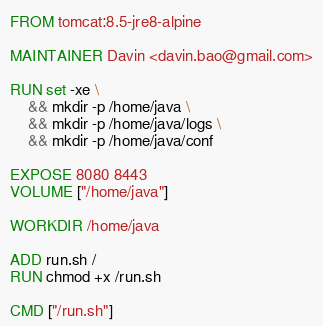<code> <loc_0><loc_0><loc_500><loc_500><_Dockerfile_>FROM tomcat:8.5-jre8-alpine

MAINTAINER Davin <davin.bao@gmail.com>

RUN set -xe \
    && mkdir -p /home/java \
    && mkdir -p /home/java/logs \
    && mkdir -p /home/java/conf
	
EXPOSE 8080 8443
VOLUME ["/home/java"]

WORKDIR /home/java

ADD run.sh /
RUN chmod +x /run.sh

CMD ["/run.sh"]
</code> 